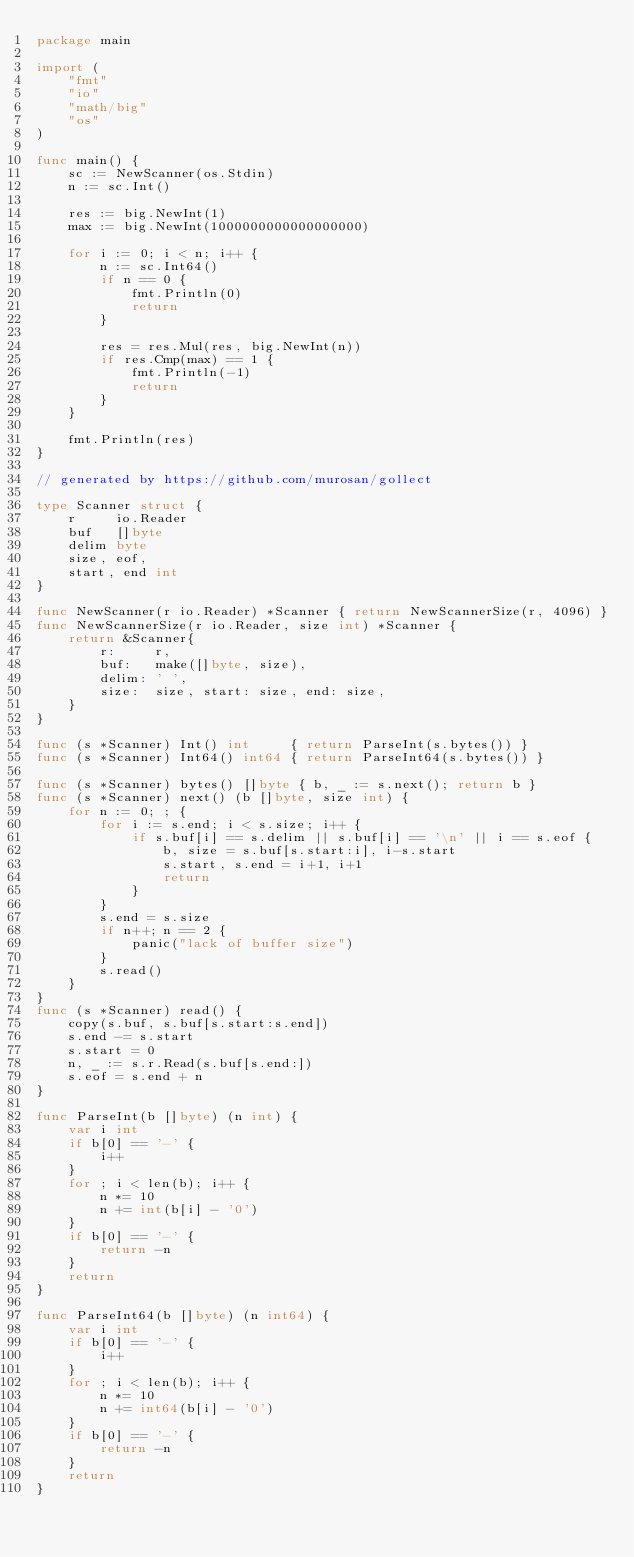Convert code to text. <code><loc_0><loc_0><loc_500><loc_500><_Go_>package main

import (
	"fmt"
	"io"
	"math/big"
	"os"
)

func main() {
	sc := NewScanner(os.Stdin)
	n := sc.Int()

	res := big.NewInt(1)
	max := big.NewInt(1000000000000000000)

	for i := 0; i < n; i++ {
		n := sc.Int64()
		if n == 0 {
			fmt.Println(0)
			return
		}

		res = res.Mul(res, big.NewInt(n))
		if res.Cmp(max) == 1 {
			fmt.Println(-1)
			return
		}
	}

	fmt.Println(res)
}

// generated by https://github.com/murosan/gollect

type Scanner struct {
	r     io.Reader
	buf   []byte
	delim byte
	size, eof,
	start, end int
}

func NewScanner(r io.Reader) *Scanner { return NewScannerSize(r, 4096) }
func NewScannerSize(r io.Reader, size int) *Scanner {
	return &Scanner{
		r:     r,
		buf:   make([]byte, size),
		delim: ' ',
		size:  size, start: size, end: size,
	}
}

func (s *Scanner) Int() int     { return ParseInt(s.bytes()) }
func (s *Scanner) Int64() int64 { return ParseInt64(s.bytes()) }

func (s *Scanner) bytes() []byte { b, _ := s.next(); return b }
func (s *Scanner) next() (b []byte, size int) {
	for n := 0; ; {
		for i := s.end; i < s.size; i++ {
			if s.buf[i] == s.delim || s.buf[i] == '\n' || i == s.eof {
				b, size = s.buf[s.start:i], i-s.start
				s.start, s.end = i+1, i+1
				return
			}
		}
		s.end = s.size
		if n++; n == 2 {
			panic("lack of buffer size")
		}
		s.read()
	}
}
func (s *Scanner) read() {
	copy(s.buf, s.buf[s.start:s.end])
	s.end -= s.start
	s.start = 0
	n, _ := s.r.Read(s.buf[s.end:])
	s.eof = s.end + n
}

func ParseInt(b []byte) (n int) {
	var i int
	if b[0] == '-' {
		i++
	}
	for ; i < len(b); i++ {
		n *= 10
		n += int(b[i] - '0')
	}
	if b[0] == '-' {
		return -n
	}
	return
}

func ParseInt64(b []byte) (n int64) {
	var i int
	if b[0] == '-' {
		i++
	}
	for ; i < len(b); i++ {
		n *= 10
		n += int64(b[i] - '0')
	}
	if b[0] == '-' {
		return -n
	}
	return
}
</code> 